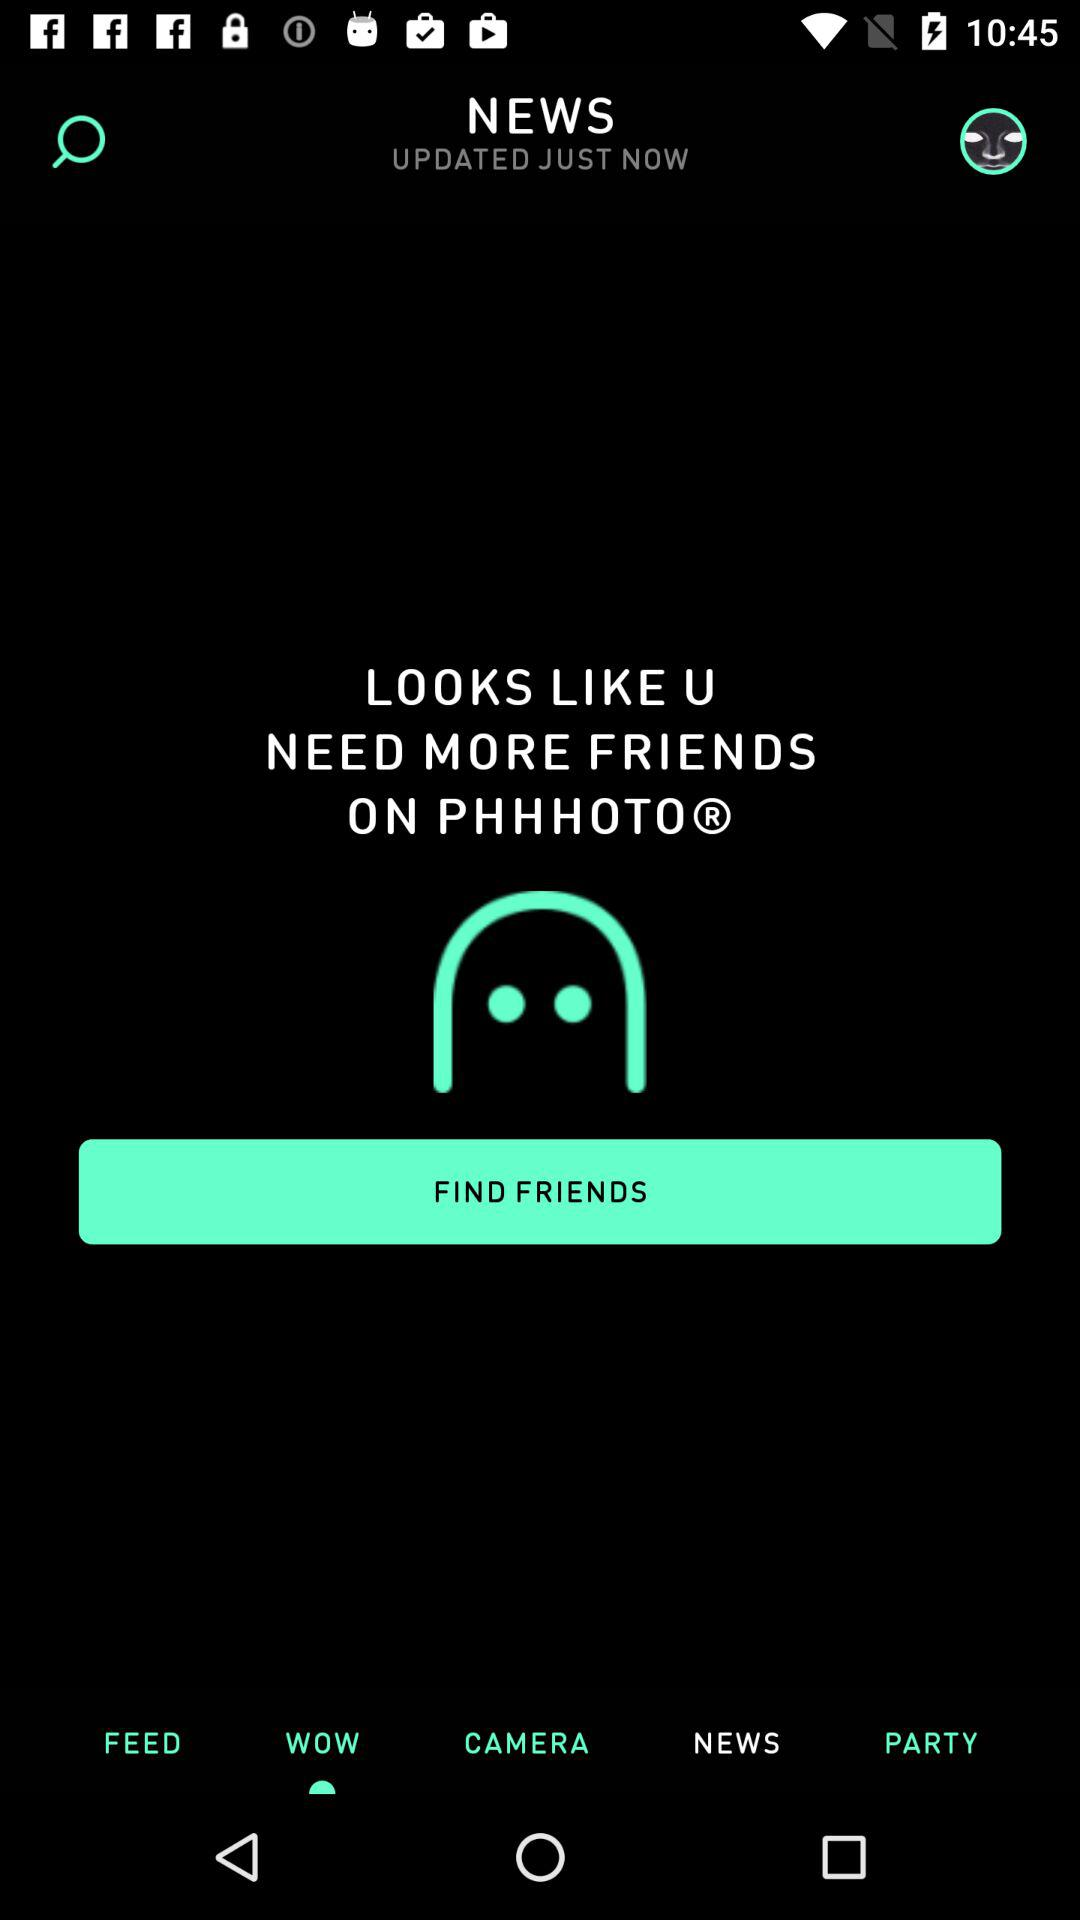Which tab is not selected? The tabs not selected are "FEED", "WOW", "CAMERA" and "PARTY". 